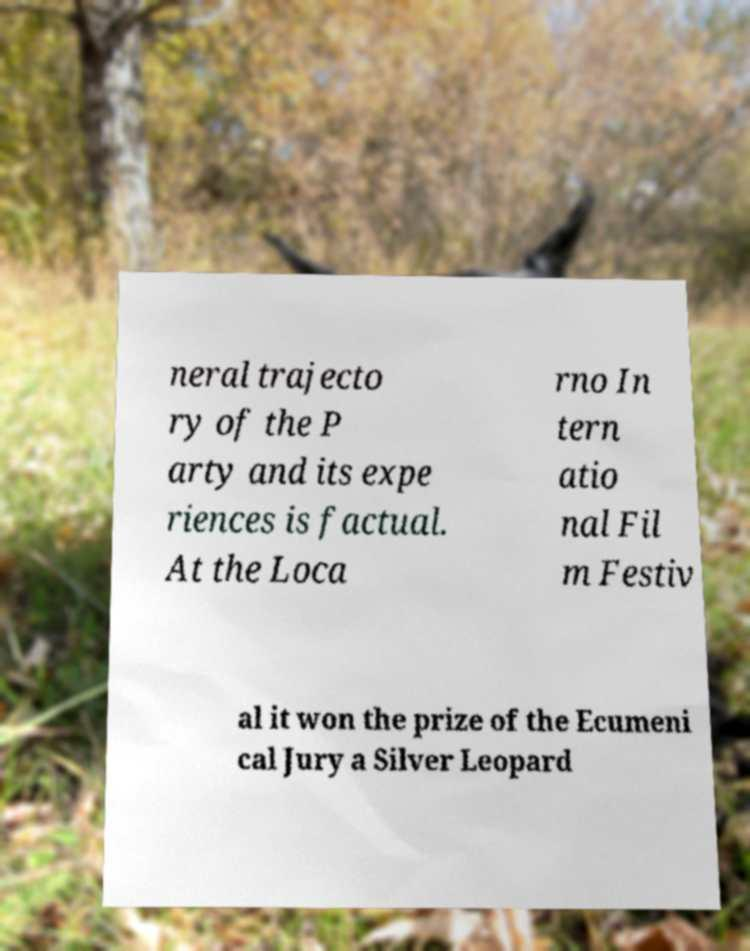What messages or text are displayed in this image? I need them in a readable, typed format. neral trajecto ry of the P arty and its expe riences is factual. At the Loca rno In tern atio nal Fil m Festiv al it won the prize of the Ecumeni cal Jury a Silver Leopard 